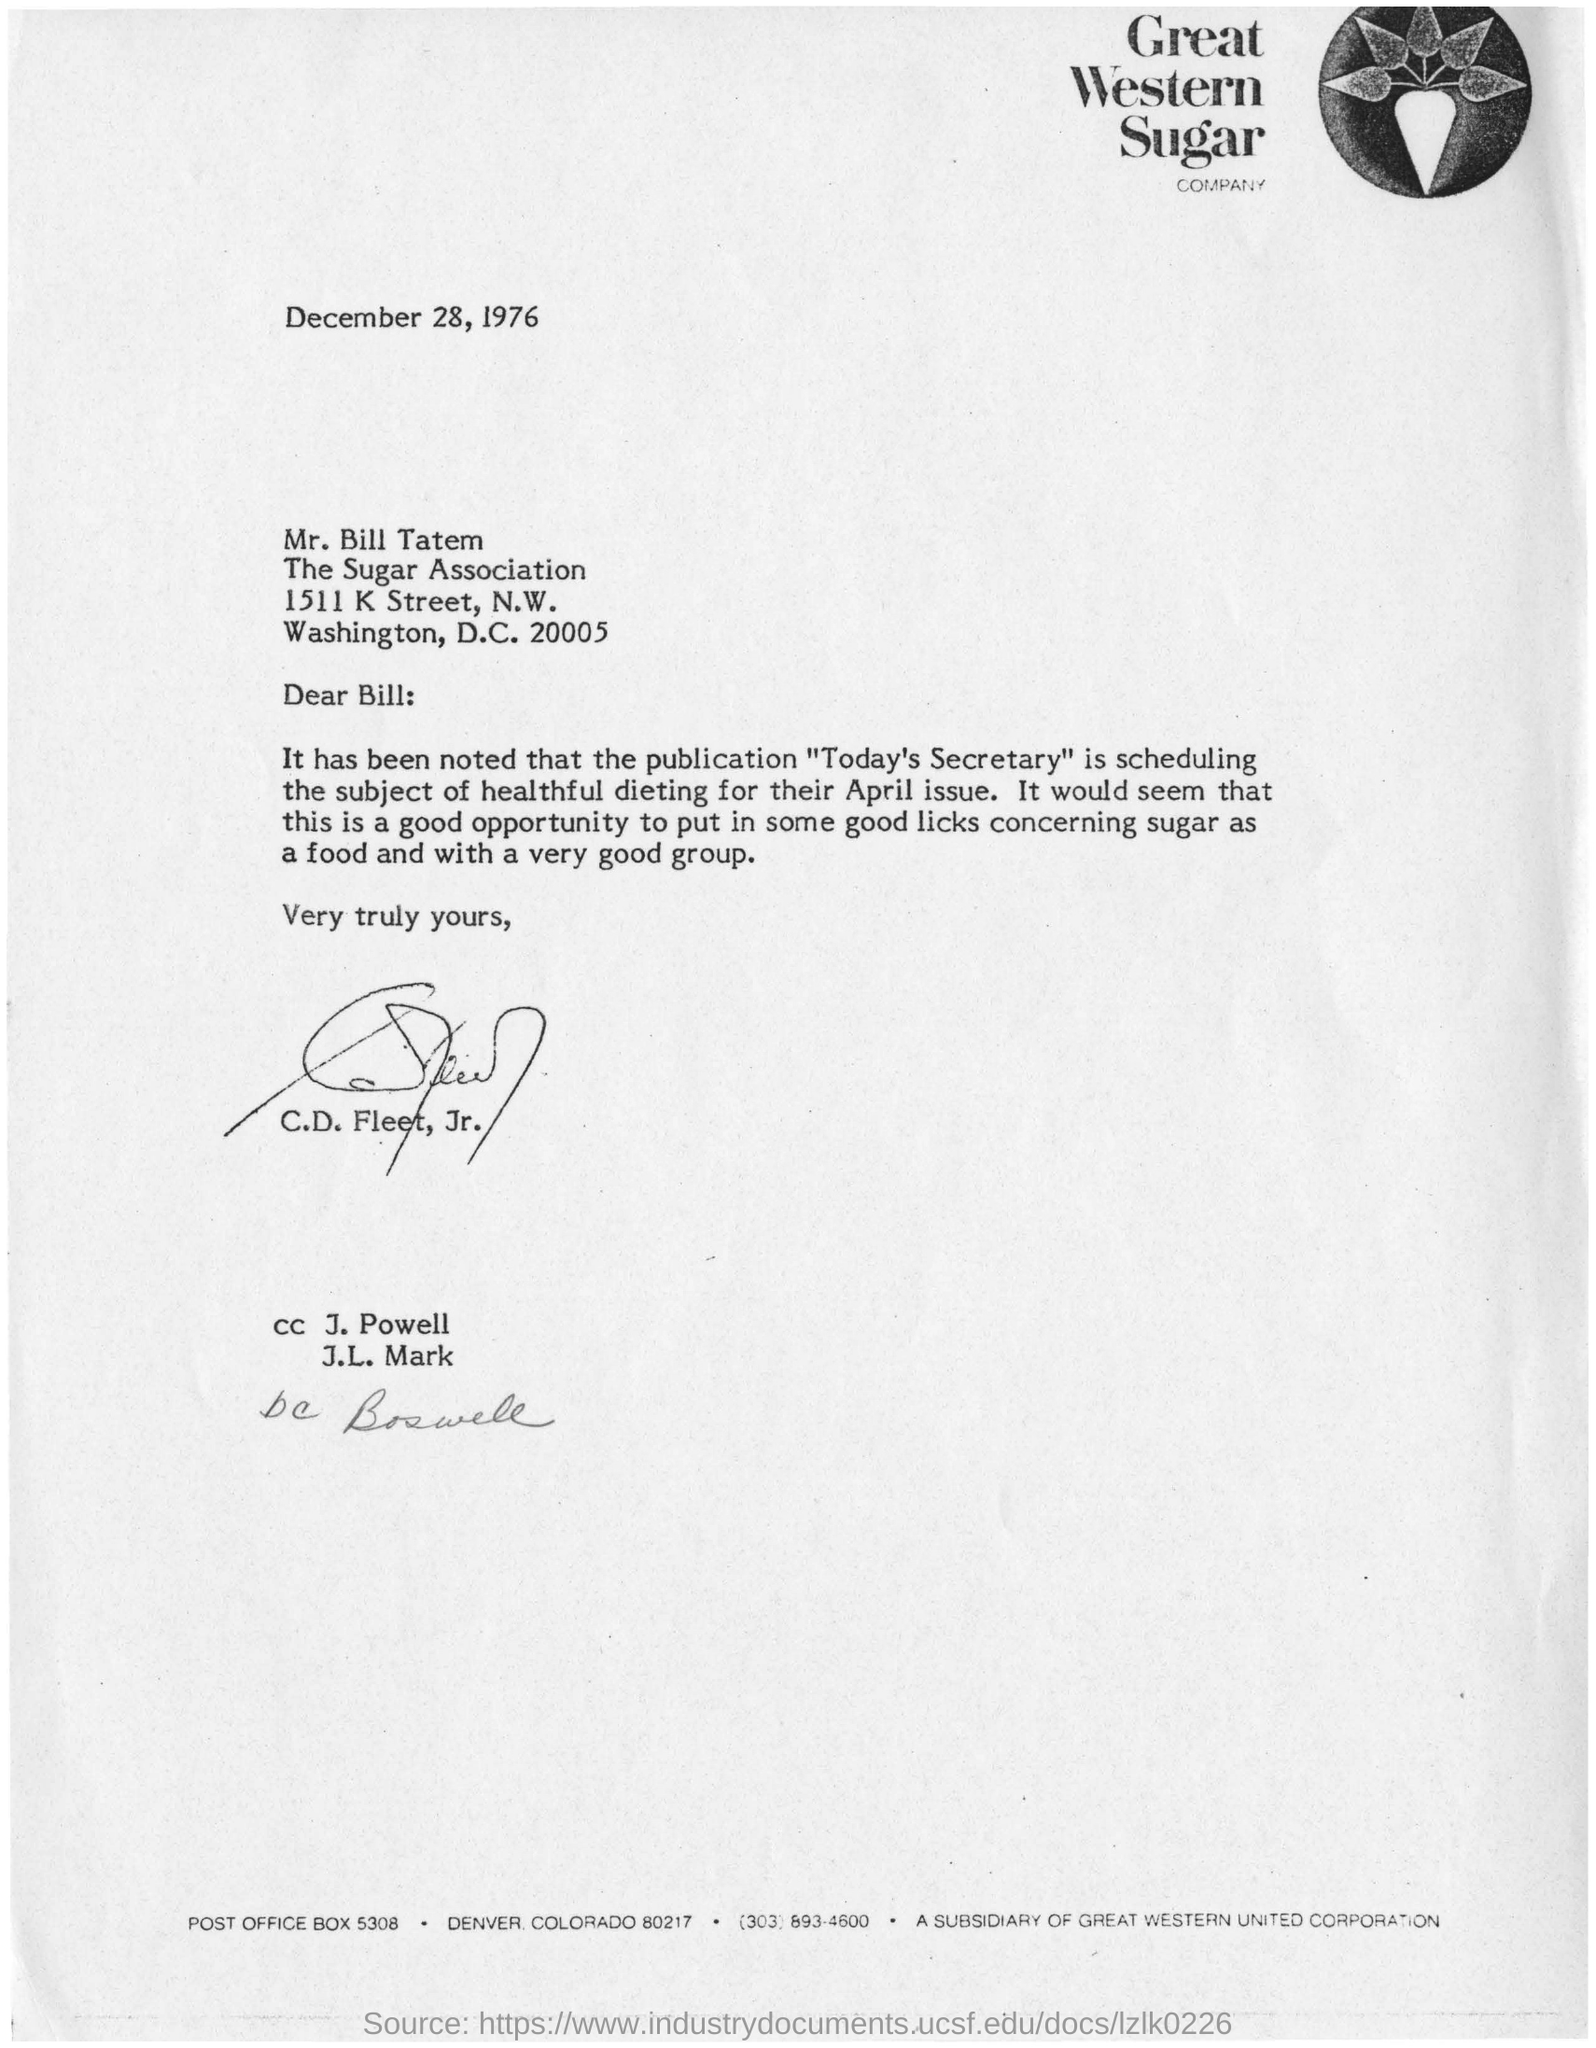Highlight a few significant elements in this photo. C.D. Fleet, Jr. is the sender of this letter. The date mentioned in this letter is December 28, 1976. The Sugar Association is located in the city of Washington, D.C. The letterhead mentions Great Western Sugar Company. Today's Secretary will be publishing an article about healthful dieting. 